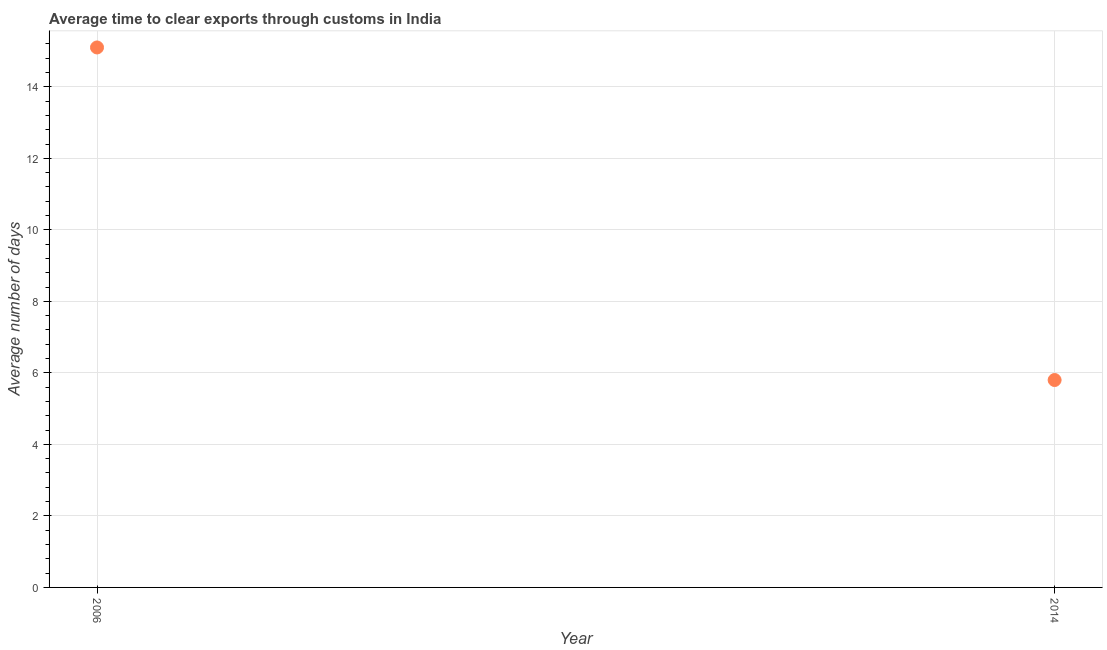What is the time to clear exports through customs in 2014?
Provide a succinct answer. 5.8. Across all years, what is the maximum time to clear exports through customs?
Give a very brief answer. 15.1. In which year was the time to clear exports through customs maximum?
Keep it short and to the point. 2006. In which year was the time to clear exports through customs minimum?
Your response must be concise. 2014. What is the sum of the time to clear exports through customs?
Make the answer very short. 20.9. What is the difference between the time to clear exports through customs in 2006 and 2014?
Ensure brevity in your answer.  9.3. What is the average time to clear exports through customs per year?
Ensure brevity in your answer.  10.45. What is the median time to clear exports through customs?
Offer a terse response. 10.45. Do a majority of the years between 2006 and 2014 (inclusive) have time to clear exports through customs greater than 6.4 days?
Give a very brief answer. No. What is the ratio of the time to clear exports through customs in 2006 to that in 2014?
Provide a succinct answer. 2.6. Is the time to clear exports through customs in 2006 less than that in 2014?
Your response must be concise. No. Does the time to clear exports through customs monotonically increase over the years?
Give a very brief answer. No. How many dotlines are there?
Ensure brevity in your answer.  1. How many years are there in the graph?
Your response must be concise. 2. What is the difference between two consecutive major ticks on the Y-axis?
Your response must be concise. 2. Are the values on the major ticks of Y-axis written in scientific E-notation?
Give a very brief answer. No. Does the graph contain any zero values?
Give a very brief answer. No. Does the graph contain grids?
Your answer should be compact. Yes. What is the title of the graph?
Give a very brief answer. Average time to clear exports through customs in India. What is the label or title of the X-axis?
Offer a terse response. Year. What is the label or title of the Y-axis?
Make the answer very short. Average number of days. What is the difference between the Average number of days in 2006 and 2014?
Offer a very short reply. 9.3. What is the ratio of the Average number of days in 2006 to that in 2014?
Your answer should be very brief. 2.6. 